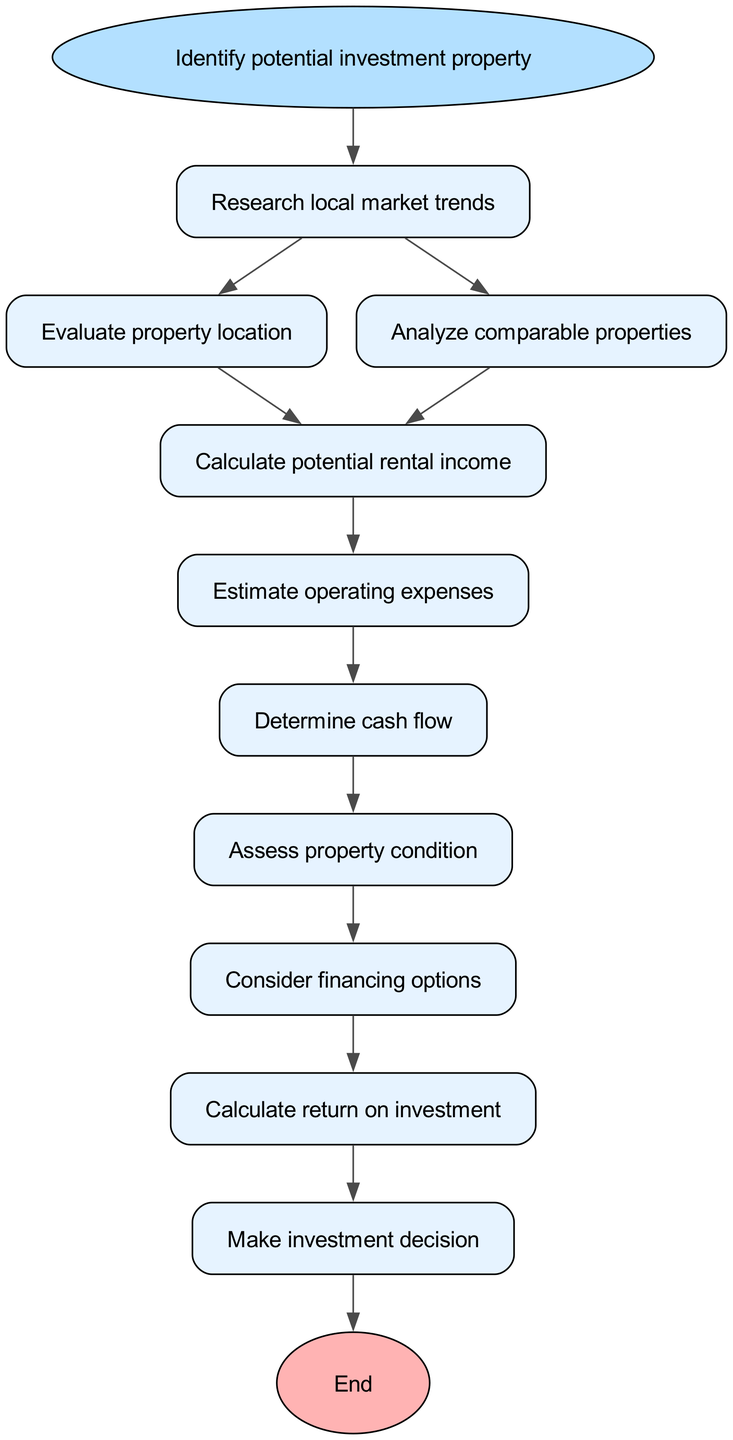What is the first step in the process? The first step in the process is indicated by the start node, which is labeled "Identify potential investment property." This is the initial action required to begin the analysis.
Answer: Identify potential investment property How many total steps are indicated in the diagram? The diagram lists a total of ten steps (including the start and end) that guide the process of analyzing a potential real estate investment property.
Answer: Ten Which step comes after "Analyze comparable properties"? According to the flow of the diagram, the step that follows "Analyze comparable properties" is "Calculate potential rental income." The flow is directed from the node for analyzing comparable properties directly to calculating rental income.
Answer: Calculate potential rental income What are the final actions before making an investment decision? Before making an investment decision, the final actions are "Calculate return on investment" and "Consider financing options." Both steps must be completed prior to reaching the final decision node.
Answer: Calculate return on investment and Consider financing options What is the last step in the analysis process? The last step in the analysis process is shown as "Make investment decision." This is the concluding action in evaluating potential investment based on all previously gathered information and calculations.
Answer: Make investment decision If you complete "Estimate operating expenses," which step do you proceed to next? After completing "Estimate operating expenses," the next step according to the flow chart is "Determine cash flow." This shows the progression in the decision-making process.
Answer: Determine cash flow Which two steps can occur after the initial step? Following the initial step "Identify potential investment property," you can either proceed to "Research local market trends" or "Analyze comparable properties." These two filters provide further insight into the investment property.
Answer: Research local market trends and Analyze comparable properties What should be considered after assessing property condition? After assessing property condition, one should consider "financing options." This step is important to evaluate how the property will be financed, impacting overall investment viability.
Answer: Consider financing options 